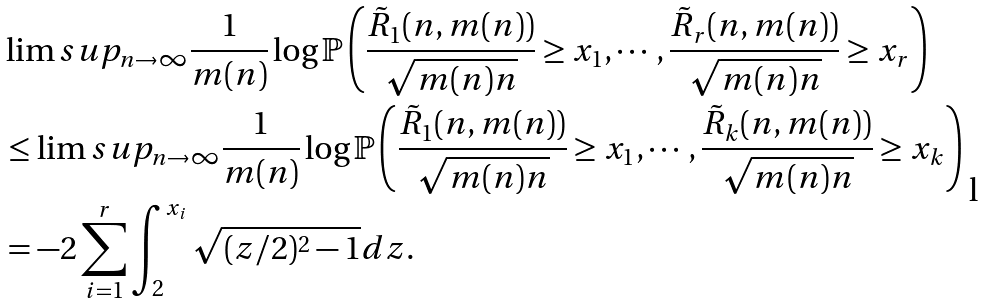<formula> <loc_0><loc_0><loc_500><loc_500>& \lim s u p _ { n \to \infty } \frac { 1 } { m ( n ) } \log \mathbb { P } \left ( \frac { \tilde { R } _ { 1 } ( n , m ( n ) ) } { \sqrt { m ( n ) n } } \geq x _ { 1 } , \cdots , \frac { \tilde { R } _ { r } ( n , m ( n ) ) } { \sqrt { m ( n ) n } } \geq x _ { r } \right ) \\ & \leq \lim s u p _ { n \to \infty } \frac { 1 } { m ( n ) } \log \mathbb { P } \left ( \frac { \tilde { R } _ { 1 } ( n , m ( n ) ) } { \sqrt { m ( n ) n } } \geq x _ { 1 } , \cdots , \frac { \tilde { R } _ { k } ( n , m ( n ) ) } { \sqrt { m ( n ) n } } \geq x _ { k } \right ) \\ & = - 2 \sum _ { i = 1 } ^ { r } \int _ { 2 } ^ { x _ { i } } \sqrt { ( z / 2 ) ^ { 2 } - 1 } d z .</formula> 